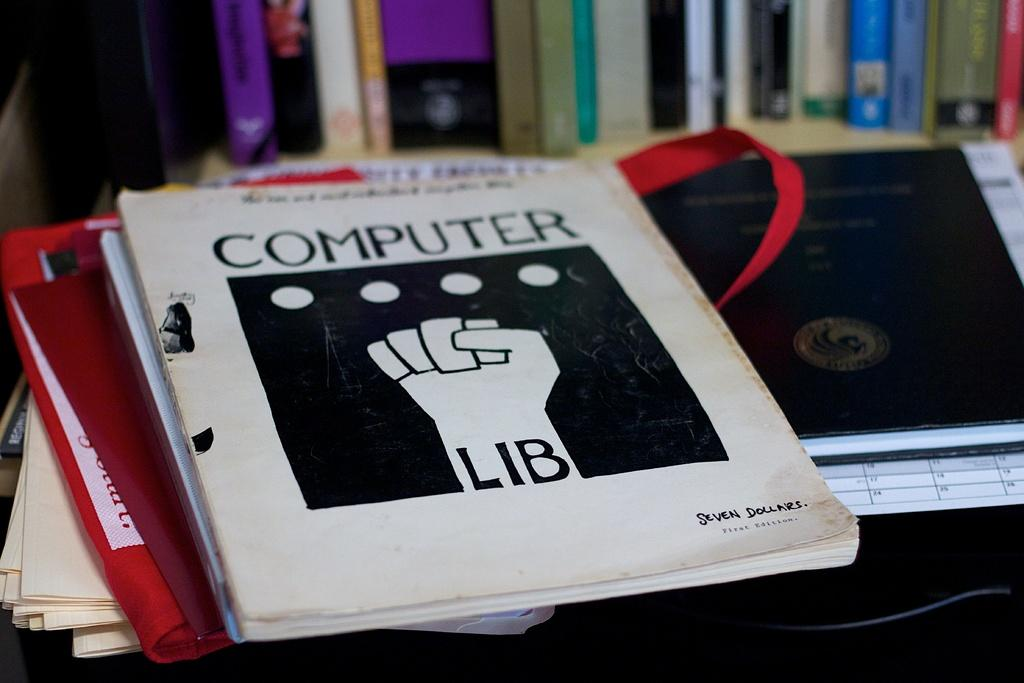<image>
Share a concise interpretation of the image provided. A small book called Computer Lib shows a raised fist on the cover. 